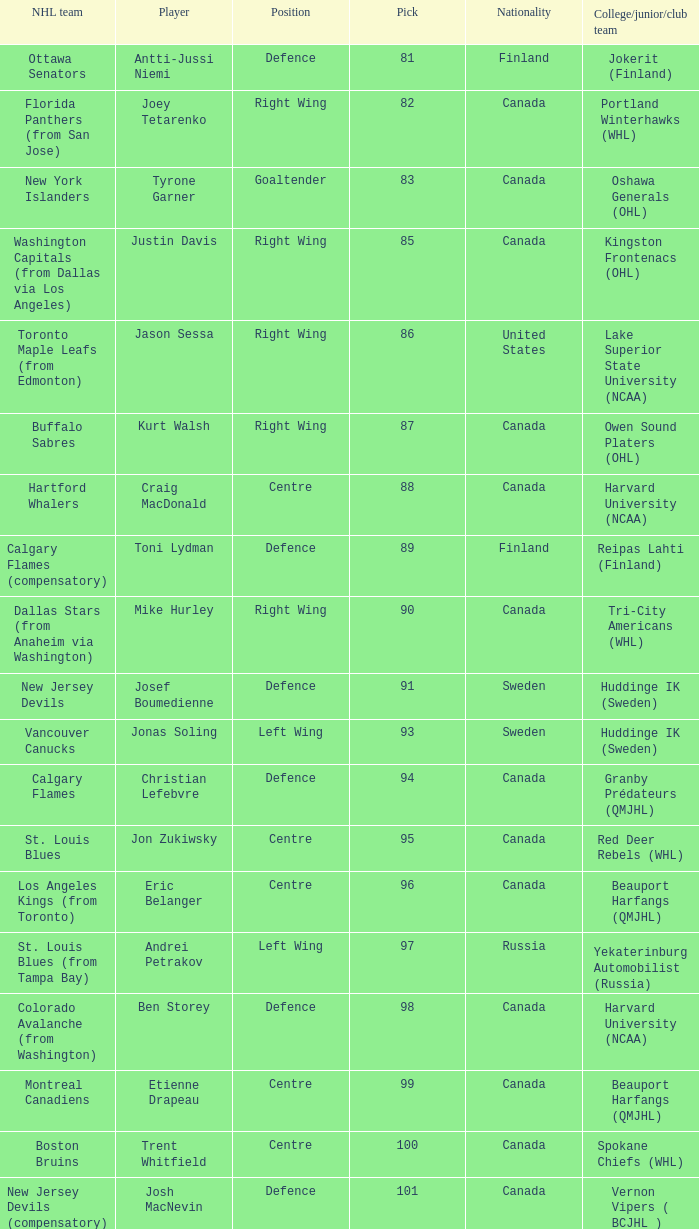What position does that draft pick play from Lake Superior State University (NCAA)? Right Wing. 